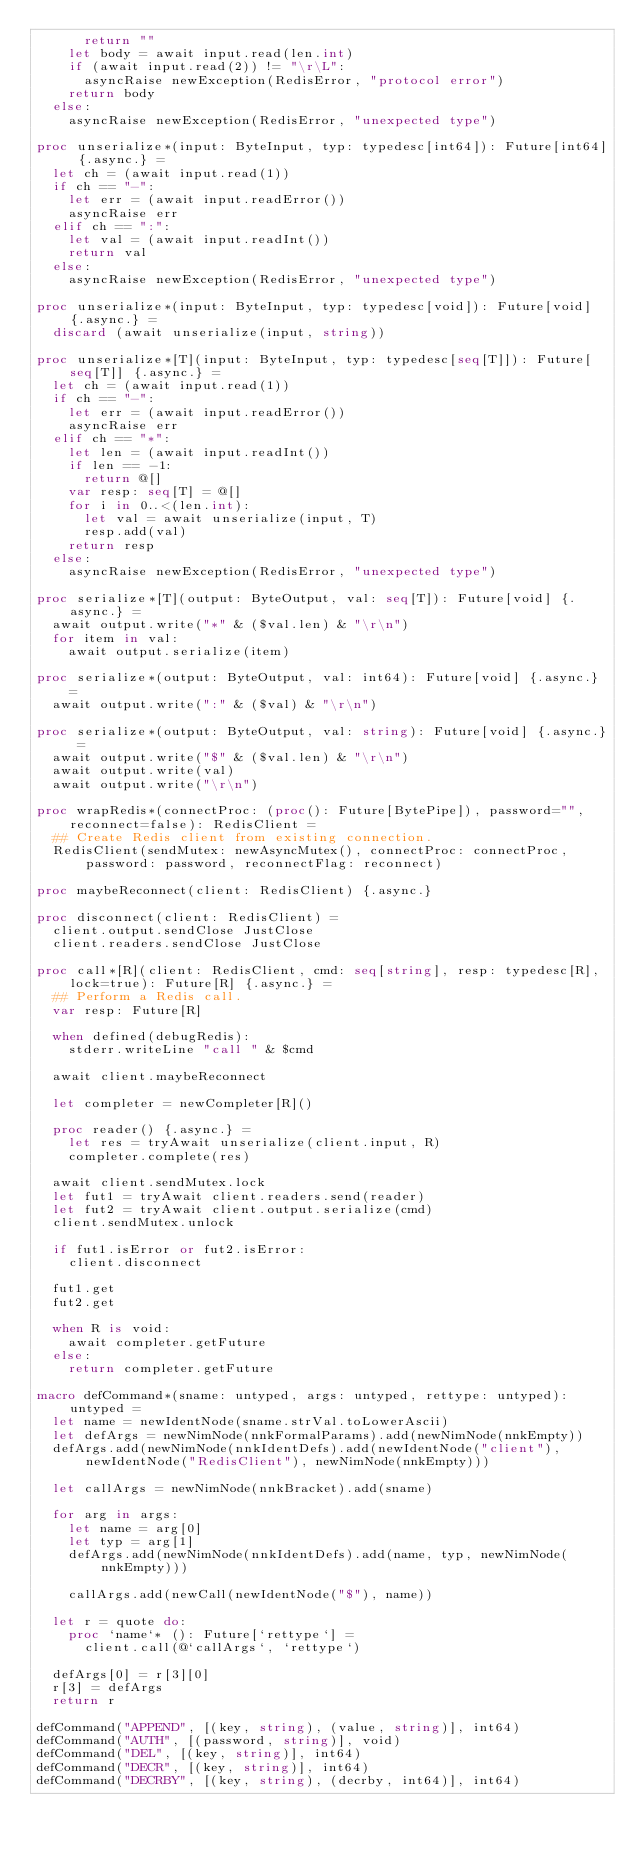<code> <loc_0><loc_0><loc_500><loc_500><_Nim_>      return ""
    let body = await input.read(len.int)
    if (await input.read(2)) != "\r\L":
      asyncRaise newException(RedisError, "protocol error")
    return body
  else:
    asyncRaise newException(RedisError, "unexpected type")

proc unserialize*(input: ByteInput, typ: typedesc[int64]): Future[int64] {.async.} =
  let ch = (await input.read(1))
  if ch == "-":
    let err = (await input.readError())
    asyncRaise err
  elif ch == ":":
    let val = (await input.readInt())
    return val
  else:
    asyncRaise newException(RedisError, "unexpected type")

proc unserialize*(input: ByteInput, typ: typedesc[void]): Future[void] {.async.} =
  discard (await unserialize(input, string))

proc unserialize*[T](input: ByteInput, typ: typedesc[seq[T]]): Future[seq[T]] {.async.} =
  let ch = (await input.read(1))
  if ch == "-":
    let err = (await input.readError())
    asyncRaise err
  elif ch == "*":
    let len = (await input.readInt())
    if len == -1:
      return @[]
    var resp: seq[T] = @[]
    for i in 0..<(len.int):
      let val = await unserialize(input, T)
      resp.add(val)
    return resp
  else:
    asyncRaise newException(RedisError, "unexpected type")

proc serialize*[T](output: ByteOutput, val: seq[T]): Future[void] {.async.} =
  await output.write("*" & ($val.len) & "\r\n")
  for item in val:
    await output.serialize(item)

proc serialize*(output: ByteOutput, val: int64): Future[void] {.async.} =
  await output.write(":" & ($val) & "\r\n")

proc serialize*(output: ByteOutput, val: string): Future[void] {.async.} =
  await output.write("$" & ($val.len) & "\r\n")
  await output.write(val)
  await output.write("\r\n")

proc wrapRedis*(connectProc: (proc(): Future[BytePipe]), password="", reconnect=false): RedisClient =
  ## Create Redis client from existing connection.
  RedisClient(sendMutex: newAsyncMutex(), connectProc: connectProc, password: password, reconnectFlag: reconnect)

proc maybeReconnect(client: RedisClient) {.async.}

proc disconnect(client: RedisClient) =
  client.output.sendClose JustClose
  client.readers.sendClose JustClose

proc call*[R](client: RedisClient, cmd: seq[string], resp: typedesc[R], lock=true): Future[R] {.async.} =
  ## Perform a Redis call.
  var resp: Future[R]

  when defined(debugRedis):
    stderr.writeLine "call " & $cmd

  await client.maybeReconnect

  let completer = newCompleter[R]()

  proc reader() {.async.} =
    let res = tryAwait unserialize(client.input, R)
    completer.complete(res)

  await client.sendMutex.lock
  let fut1 = tryAwait client.readers.send(reader)
  let fut2 = tryAwait client.output.serialize(cmd)
  client.sendMutex.unlock

  if fut1.isError or fut2.isError:
    client.disconnect

  fut1.get
  fut2.get

  when R is void:
    await completer.getFuture
  else:
    return completer.getFuture

macro defCommand*(sname: untyped, args: untyped, rettype: untyped): untyped =
  let name = newIdentNode(sname.strVal.toLowerAscii)
  let defArgs = newNimNode(nnkFormalParams).add(newNimNode(nnkEmpty))
  defArgs.add(newNimNode(nnkIdentDefs).add(newIdentNode("client"), newIdentNode("RedisClient"), newNimNode(nnkEmpty)))

  let callArgs = newNimNode(nnkBracket).add(sname)

  for arg in args:
    let name = arg[0]
    let typ = arg[1]
    defArgs.add(newNimNode(nnkIdentDefs).add(name, typ, newNimNode(nnkEmpty)))

    callArgs.add(newCall(newIdentNode("$"), name))

  let r = quote do:
    proc `name`* (): Future[`rettype`] =
      client.call(@`callArgs`, `rettype`)

  defArgs[0] = r[3][0]
  r[3] = defArgs
  return r

defCommand("APPEND", [(key, string), (value, string)], int64)
defCommand("AUTH", [(password, string)], void)
defCommand("DEL", [(key, string)], int64)
defCommand("DECR", [(key, string)], int64)
defCommand("DECRBY", [(key, string), (decrby, int64)], int64)</code> 